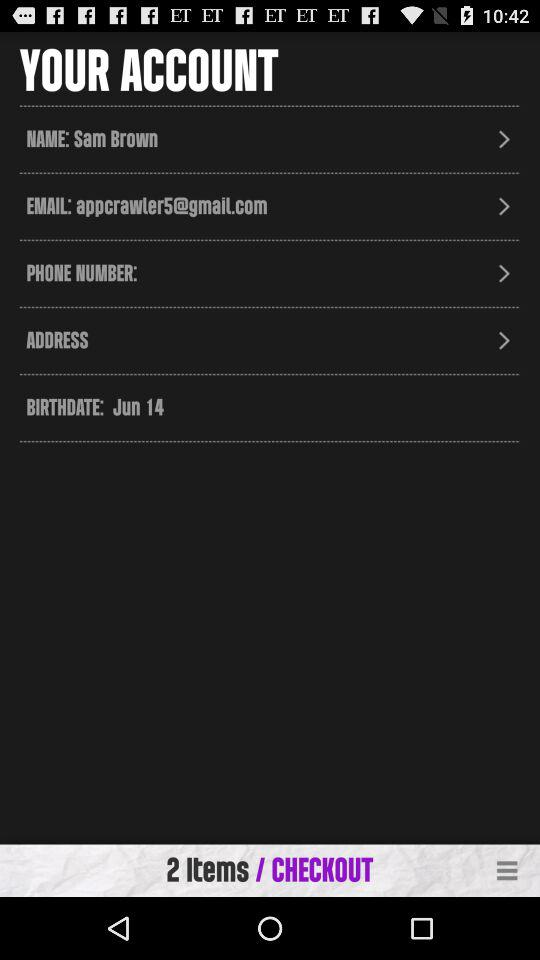What is the profile name? The profile name is Sam Brown. 